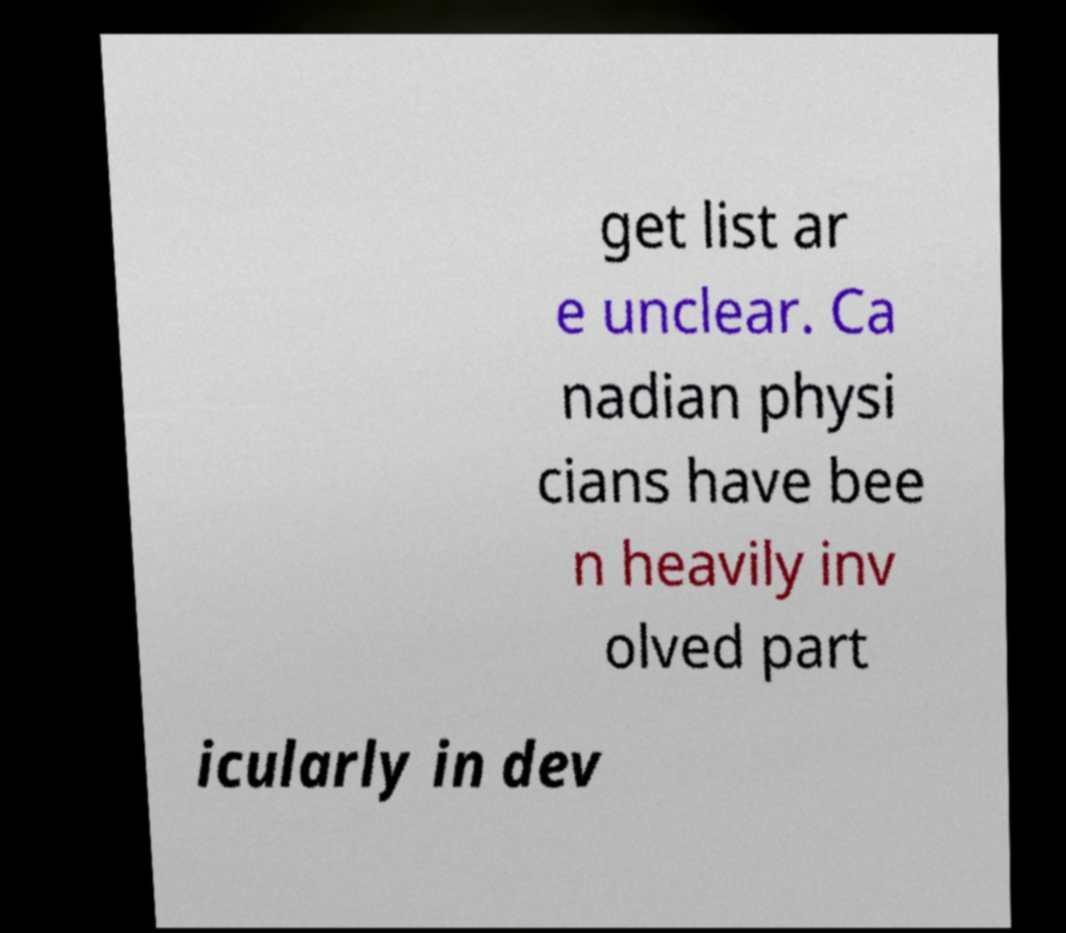For documentation purposes, I need the text within this image transcribed. Could you provide that? get list ar e unclear. Ca nadian physi cians have bee n heavily inv olved part icularly in dev 